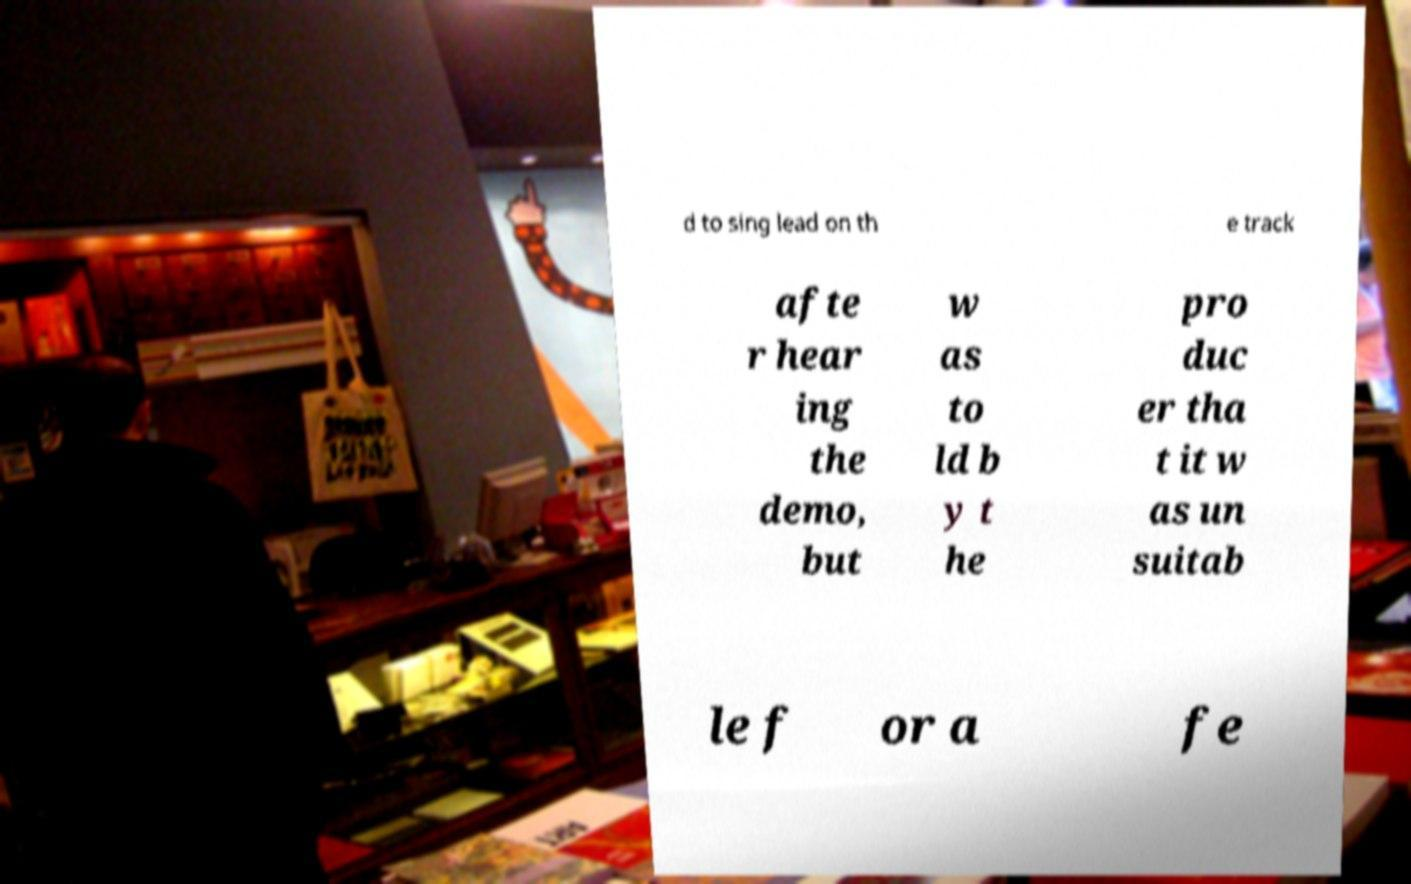I need the written content from this picture converted into text. Can you do that? d to sing lead on th e track afte r hear ing the demo, but w as to ld b y t he pro duc er tha t it w as un suitab le f or a fe 